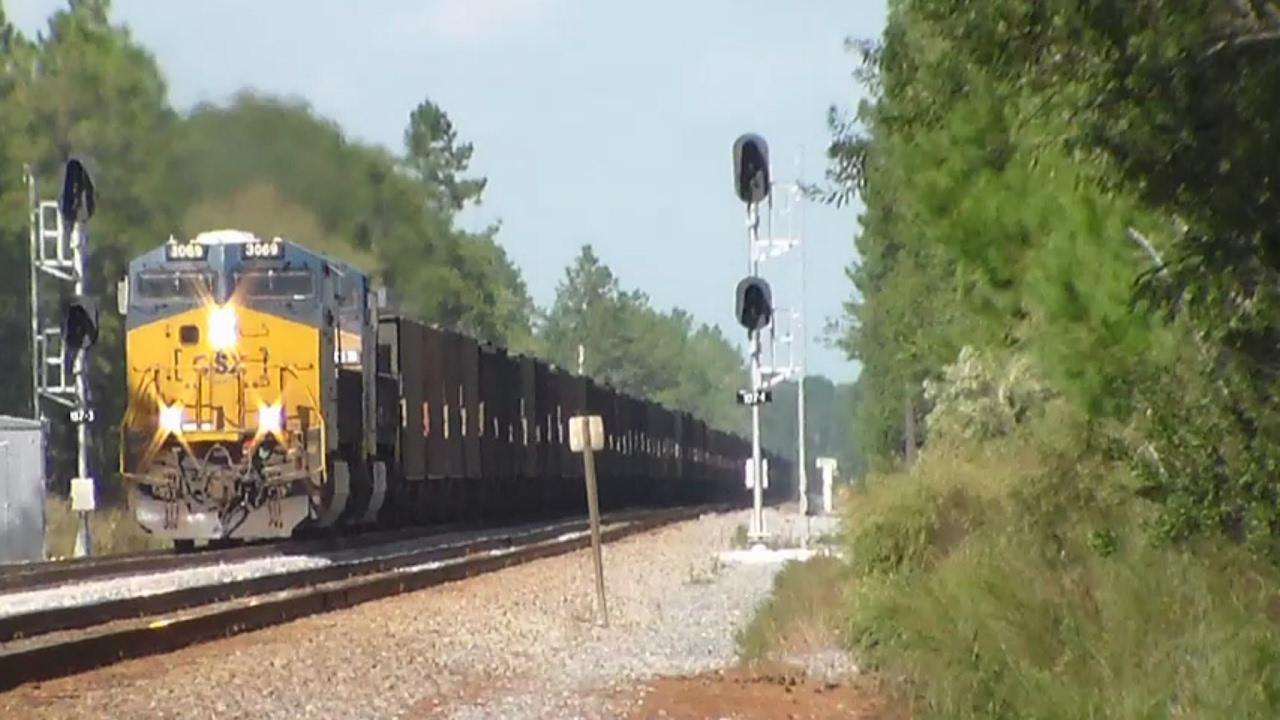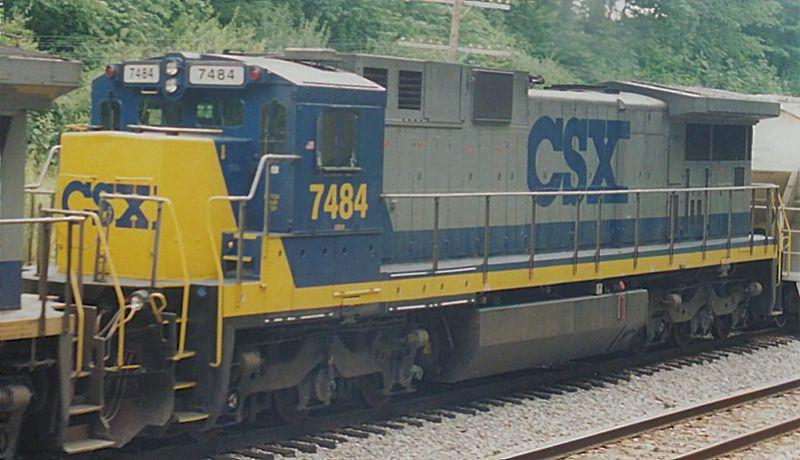The first image is the image on the left, the second image is the image on the right. Given the left and right images, does the statement "Left image shows a blue and yellow train that his heading rightward." hold true? Answer yes or no. No. The first image is the image on the left, the second image is the image on the right. Analyze the images presented: Is the assertion "A total of two trains are headed on the same direction." valid? Answer yes or no. Yes. 